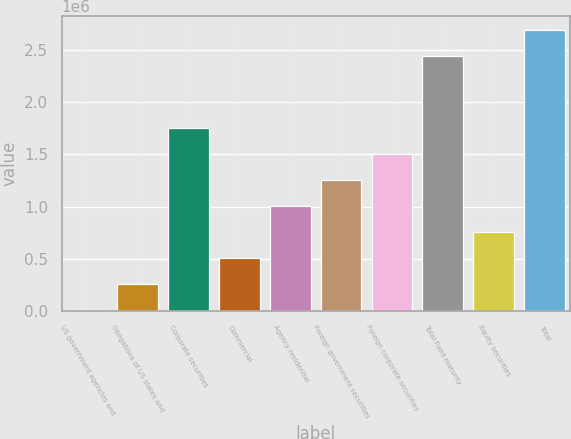Convert chart. <chart><loc_0><loc_0><loc_500><loc_500><bar_chart><fcel>US government agencies and<fcel>Obligations of US states and<fcel>Corporate securities<fcel>Commercial<fcel>Agency residential<fcel>Foreign government securities<fcel>Foreign corporate securities<fcel>Total fixed maturity<fcel>Equity securities<fcel>Total<nl><fcel>13187<fcel>261429<fcel>1.75088e+06<fcel>509672<fcel>1.00616e+06<fcel>1.2544e+06<fcel>1.50264e+06<fcel>2.44533e+06<fcel>757914<fcel>2.69357e+06<nl></chart> 